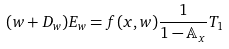Convert formula to latex. <formula><loc_0><loc_0><loc_500><loc_500>( w + D _ { w } ) E _ { w } = f ( x , w ) \frac { 1 } { 1 - \mathbb { A } _ { x } } T _ { 1 }</formula> 